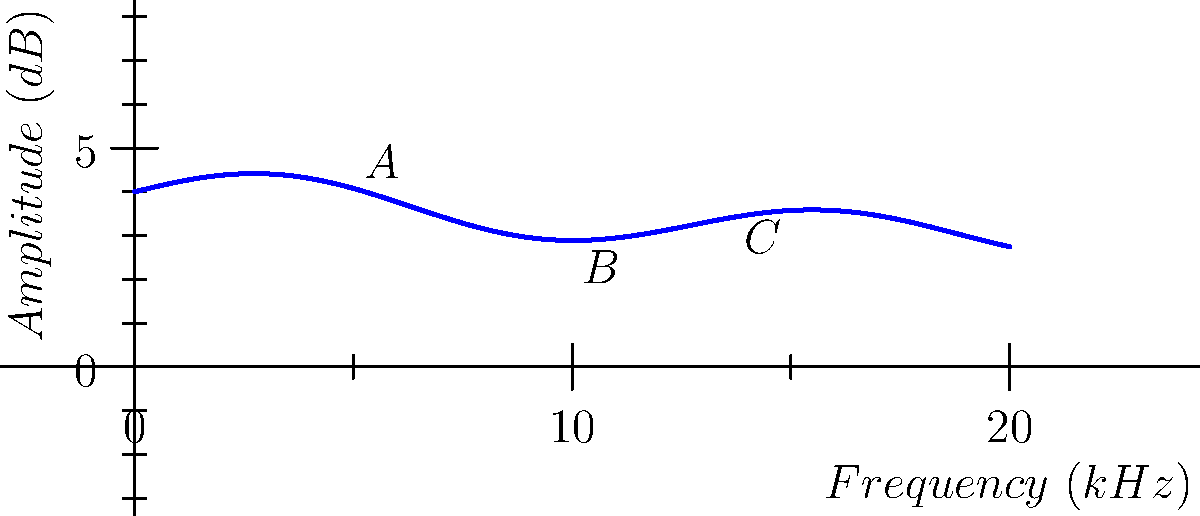Examine the frequency response curve of the AKG C414 XLII microphone shown above. What characteristic of this microphone's performance does the peak at point A (around 5 kHz) likely represent? To answer this question, we need to analyze the frequency response curve and understand its implications for microphone performance:

1. The curve shows the microphone's sensitivity to different frequencies.
2. The x-axis represents frequency in kHz, and the y-axis represents amplitude in dB.
3. Point A shows a peak in the curve around 5 kHz.
4. In microphone design, a boost in the 3-6 kHz range is often intentional.
5. This boost typically corresponds to the "presence" range of human vocals and many instruments.
6. The presence boost enhances clarity and intelligibility in this critical frequency range.
7. For the AKG C414 XLII, this peak likely represents a deliberately engineered presence boost.
8. This feature makes the microphone particularly suitable for recording vocals and acoustic instruments, where clarity in this range is desirable.
Answer: Presence boost 